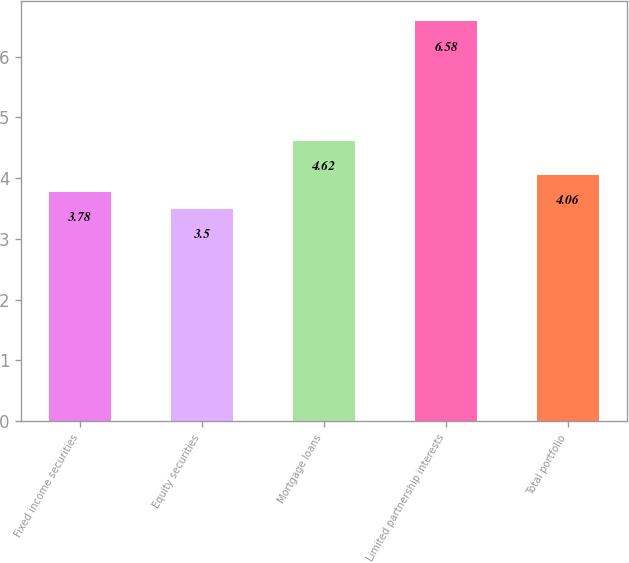Convert chart to OTSL. <chart><loc_0><loc_0><loc_500><loc_500><bar_chart><fcel>Fixed income securities<fcel>Equity securities<fcel>Mortgage loans<fcel>Limited partnership interests<fcel>Total portfolio<nl><fcel>3.78<fcel>3.5<fcel>4.62<fcel>6.58<fcel>4.06<nl></chart> 